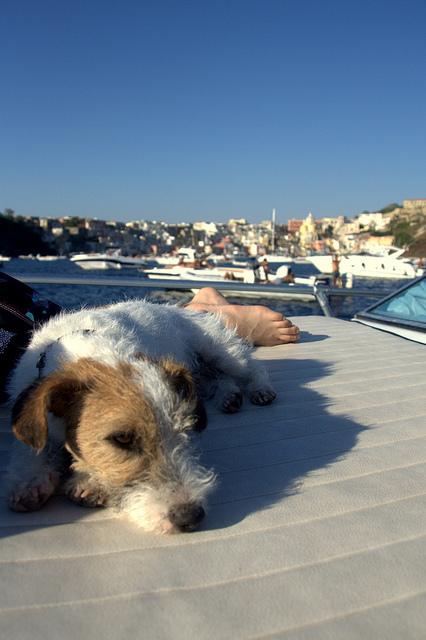What is the dog doing?
Be succinct. Laying down. How many claws are visible in the picture?
Be succinct. 16. Are there shoes on the person's feet?
Give a very brief answer. No. Where are the bare feet?
Quick response, please. Behind dog. 